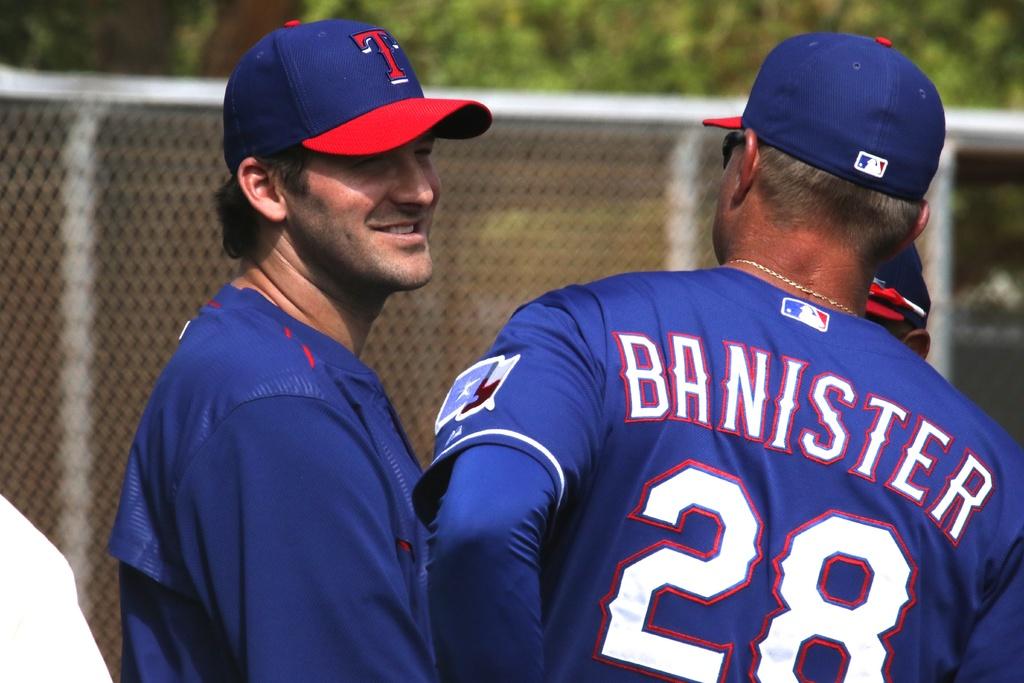What is the player's last name?
Your response must be concise. Banister. What number is on the back of the banister jersey?
Offer a very short reply. 28. 